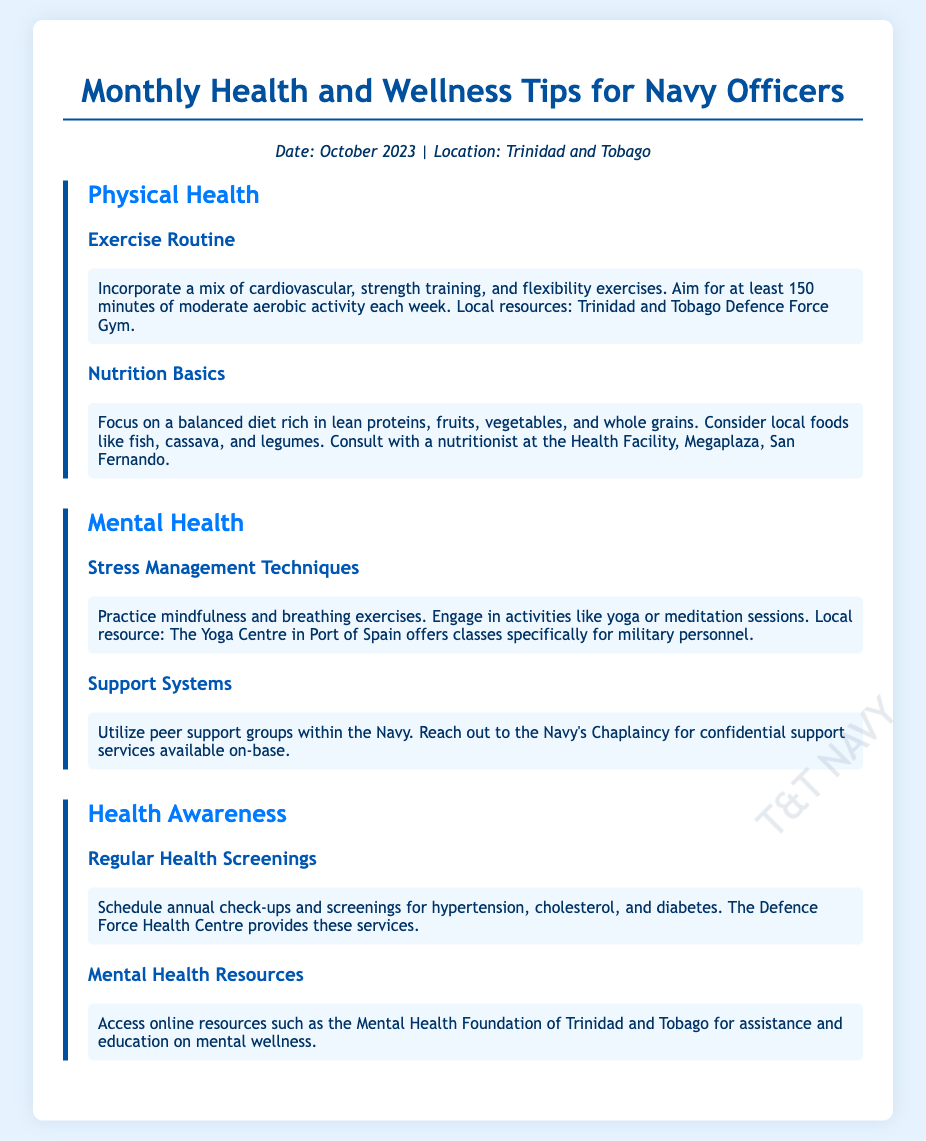What is the focus of the October 2023 tips? The document provides tips on physical and mental health for Navy officers.
Answer: Health and wellness Where can officers find local exercise resources? The document mentions the Trinidad and Tobago Defence Force Gym as a local resource for exercise.
Answer: Defence Force Gym What is the recommended amount of aerobic activity per week? The document states that officers should aim for at least 150 minutes of moderate aerobic activity each week.
Answer: 150 minutes Which local food is suggested for a balanced diet? The document lists fish, cassava, and legumes as examples of local foods for a balanced diet.
Answer: Fish, cassava, legumes What support does the Navy's Chaplaincy provide? According to the document, the Navy's Chaplaincy offers confidential support services.
Answer: Confidential support services What is one technique mentioned for stress management? The document suggests practicing mindfulness as a technique for stress management.
Answer: Mindfulness Where should officers schedule annual health check-ups? The document indicates that annual check-ups should be scheduled at the Defence Force Health Centre.
Answer: Defence Force Health Centre What online resource is recommended for mental health education? The Mental Health Foundation of Trinidad and Tobago is recommended for assistance and education on mental wellness.
Answer: Mental Health Foundation of Trinidad and Tobago 